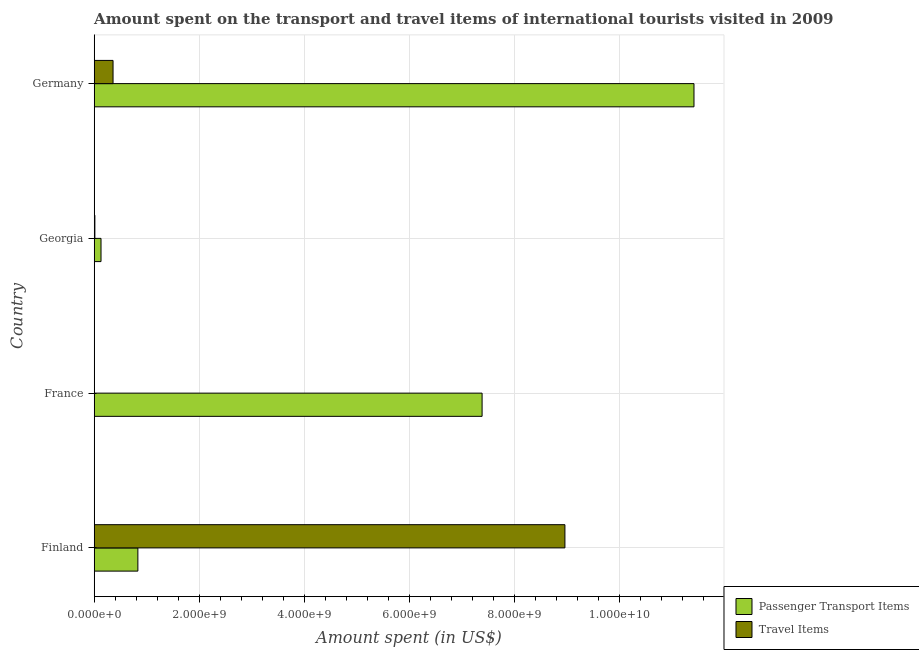How many bars are there on the 1st tick from the top?
Provide a short and direct response. 2. What is the label of the 3rd group of bars from the top?
Offer a very short reply. France. What is the amount spent in travel items in Germany?
Give a very brief answer. 3.59e+08. Across all countries, what is the maximum amount spent on passenger transport items?
Your response must be concise. 1.14e+1. Across all countries, what is the minimum amount spent on passenger transport items?
Offer a very short reply. 1.30e+08. In which country was the amount spent on passenger transport items minimum?
Make the answer very short. Georgia. What is the total amount spent in travel items in the graph?
Give a very brief answer. 9.35e+09. What is the difference between the amount spent in travel items in France and that in Georgia?
Offer a very short reply. -7.20e+06. What is the difference between the amount spent in travel items in Germany and the amount spent on passenger transport items in France?
Ensure brevity in your answer.  -7.03e+09. What is the average amount spent on passenger transport items per country?
Your answer should be very brief. 4.94e+09. What is the difference between the amount spent on passenger transport items and amount spent in travel items in Georgia?
Provide a short and direct response. 1.17e+08. In how many countries, is the amount spent on passenger transport items greater than 2400000000 US$?
Keep it short and to the point. 2. What is the ratio of the amount spent in travel items in Finland to that in Germany?
Give a very brief answer. 24.98. What is the difference between the highest and the second highest amount spent in travel items?
Provide a succinct answer. 8.61e+09. What is the difference between the highest and the lowest amount spent in travel items?
Provide a succinct answer. 8.96e+09. What does the 2nd bar from the top in Finland represents?
Your answer should be compact. Passenger Transport Items. What does the 2nd bar from the bottom in France represents?
Ensure brevity in your answer.  Travel Items. How many bars are there?
Offer a terse response. 8. How many countries are there in the graph?
Give a very brief answer. 4. What is the difference between two consecutive major ticks on the X-axis?
Provide a succinct answer. 2.00e+09. Are the values on the major ticks of X-axis written in scientific E-notation?
Your answer should be compact. Yes. Does the graph contain any zero values?
Offer a terse response. No. Does the graph contain grids?
Your answer should be very brief. Yes. How are the legend labels stacked?
Provide a short and direct response. Vertical. What is the title of the graph?
Ensure brevity in your answer.  Amount spent on the transport and travel items of international tourists visited in 2009. What is the label or title of the X-axis?
Ensure brevity in your answer.  Amount spent (in US$). What is the Amount spent (in US$) in Passenger Transport Items in Finland?
Ensure brevity in your answer.  8.32e+08. What is the Amount spent (in US$) in Travel Items in Finland?
Your answer should be compact. 8.97e+09. What is the Amount spent (in US$) of Passenger Transport Items in France?
Ensure brevity in your answer.  7.39e+09. What is the Amount spent (in US$) of Travel Items in France?
Give a very brief answer. 5.80e+06. What is the Amount spent (in US$) of Passenger Transport Items in Georgia?
Ensure brevity in your answer.  1.30e+08. What is the Amount spent (in US$) of Travel Items in Georgia?
Give a very brief answer. 1.30e+07. What is the Amount spent (in US$) of Passenger Transport Items in Germany?
Provide a short and direct response. 1.14e+1. What is the Amount spent (in US$) in Travel Items in Germany?
Provide a succinct answer. 3.59e+08. Across all countries, what is the maximum Amount spent (in US$) in Passenger Transport Items?
Provide a short and direct response. 1.14e+1. Across all countries, what is the maximum Amount spent (in US$) in Travel Items?
Ensure brevity in your answer.  8.97e+09. Across all countries, what is the minimum Amount spent (in US$) in Passenger Transport Items?
Offer a very short reply. 1.30e+08. Across all countries, what is the minimum Amount spent (in US$) in Travel Items?
Your answer should be very brief. 5.80e+06. What is the total Amount spent (in US$) of Passenger Transport Items in the graph?
Provide a succinct answer. 1.98e+1. What is the total Amount spent (in US$) of Travel Items in the graph?
Your response must be concise. 9.35e+09. What is the difference between the Amount spent (in US$) in Passenger Transport Items in Finland and that in France?
Keep it short and to the point. -6.56e+09. What is the difference between the Amount spent (in US$) of Travel Items in Finland and that in France?
Provide a succinct answer. 8.96e+09. What is the difference between the Amount spent (in US$) in Passenger Transport Items in Finland and that in Georgia?
Offer a terse response. 7.02e+08. What is the difference between the Amount spent (in US$) in Travel Items in Finland and that in Georgia?
Your answer should be compact. 8.96e+09. What is the difference between the Amount spent (in US$) in Passenger Transport Items in Finland and that in Germany?
Your response must be concise. -1.06e+1. What is the difference between the Amount spent (in US$) of Travel Items in Finland and that in Germany?
Your answer should be very brief. 8.61e+09. What is the difference between the Amount spent (in US$) of Passenger Transport Items in France and that in Georgia?
Offer a very short reply. 7.26e+09. What is the difference between the Amount spent (in US$) in Travel Items in France and that in Georgia?
Give a very brief answer. -7.20e+06. What is the difference between the Amount spent (in US$) of Passenger Transport Items in France and that in Germany?
Provide a short and direct response. -4.04e+09. What is the difference between the Amount spent (in US$) of Travel Items in France and that in Germany?
Your answer should be very brief. -3.53e+08. What is the difference between the Amount spent (in US$) of Passenger Transport Items in Georgia and that in Germany?
Give a very brief answer. -1.13e+1. What is the difference between the Amount spent (in US$) of Travel Items in Georgia and that in Germany?
Your answer should be compact. -3.46e+08. What is the difference between the Amount spent (in US$) in Passenger Transport Items in Finland and the Amount spent (in US$) in Travel Items in France?
Provide a short and direct response. 8.26e+08. What is the difference between the Amount spent (in US$) in Passenger Transport Items in Finland and the Amount spent (in US$) in Travel Items in Georgia?
Ensure brevity in your answer.  8.19e+08. What is the difference between the Amount spent (in US$) in Passenger Transport Items in Finland and the Amount spent (in US$) in Travel Items in Germany?
Make the answer very short. 4.73e+08. What is the difference between the Amount spent (in US$) of Passenger Transport Items in France and the Amount spent (in US$) of Travel Items in Georgia?
Offer a terse response. 7.38e+09. What is the difference between the Amount spent (in US$) of Passenger Transport Items in France and the Amount spent (in US$) of Travel Items in Germany?
Your answer should be very brief. 7.03e+09. What is the difference between the Amount spent (in US$) in Passenger Transport Items in Georgia and the Amount spent (in US$) in Travel Items in Germany?
Provide a short and direct response. -2.29e+08. What is the average Amount spent (in US$) of Passenger Transport Items per country?
Offer a terse response. 4.94e+09. What is the average Amount spent (in US$) of Travel Items per country?
Provide a short and direct response. 2.34e+09. What is the difference between the Amount spent (in US$) in Passenger Transport Items and Amount spent (in US$) in Travel Items in Finland?
Make the answer very short. -8.14e+09. What is the difference between the Amount spent (in US$) of Passenger Transport Items and Amount spent (in US$) of Travel Items in France?
Your answer should be compact. 7.38e+09. What is the difference between the Amount spent (in US$) in Passenger Transport Items and Amount spent (in US$) in Travel Items in Georgia?
Your answer should be very brief. 1.17e+08. What is the difference between the Amount spent (in US$) of Passenger Transport Items and Amount spent (in US$) of Travel Items in Germany?
Make the answer very short. 1.11e+1. What is the ratio of the Amount spent (in US$) of Passenger Transport Items in Finland to that in France?
Give a very brief answer. 0.11. What is the ratio of the Amount spent (in US$) in Travel Items in Finland to that in France?
Ensure brevity in your answer.  1546.21. What is the ratio of the Amount spent (in US$) in Travel Items in Finland to that in Georgia?
Ensure brevity in your answer.  689.85. What is the ratio of the Amount spent (in US$) in Passenger Transport Items in Finland to that in Germany?
Your response must be concise. 0.07. What is the ratio of the Amount spent (in US$) of Travel Items in Finland to that in Germany?
Provide a short and direct response. 24.98. What is the ratio of the Amount spent (in US$) of Passenger Transport Items in France to that in Georgia?
Your response must be concise. 56.85. What is the ratio of the Amount spent (in US$) of Travel Items in France to that in Georgia?
Your response must be concise. 0.45. What is the ratio of the Amount spent (in US$) of Passenger Transport Items in France to that in Germany?
Keep it short and to the point. 0.65. What is the ratio of the Amount spent (in US$) in Travel Items in France to that in Germany?
Your answer should be compact. 0.02. What is the ratio of the Amount spent (in US$) of Passenger Transport Items in Georgia to that in Germany?
Keep it short and to the point. 0.01. What is the ratio of the Amount spent (in US$) of Travel Items in Georgia to that in Germany?
Give a very brief answer. 0.04. What is the difference between the highest and the second highest Amount spent (in US$) in Passenger Transport Items?
Your answer should be compact. 4.04e+09. What is the difference between the highest and the second highest Amount spent (in US$) in Travel Items?
Offer a terse response. 8.61e+09. What is the difference between the highest and the lowest Amount spent (in US$) of Passenger Transport Items?
Give a very brief answer. 1.13e+1. What is the difference between the highest and the lowest Amount spent (in US$) of Travel Items?
Your answer should be compact. 8.96e+09. 